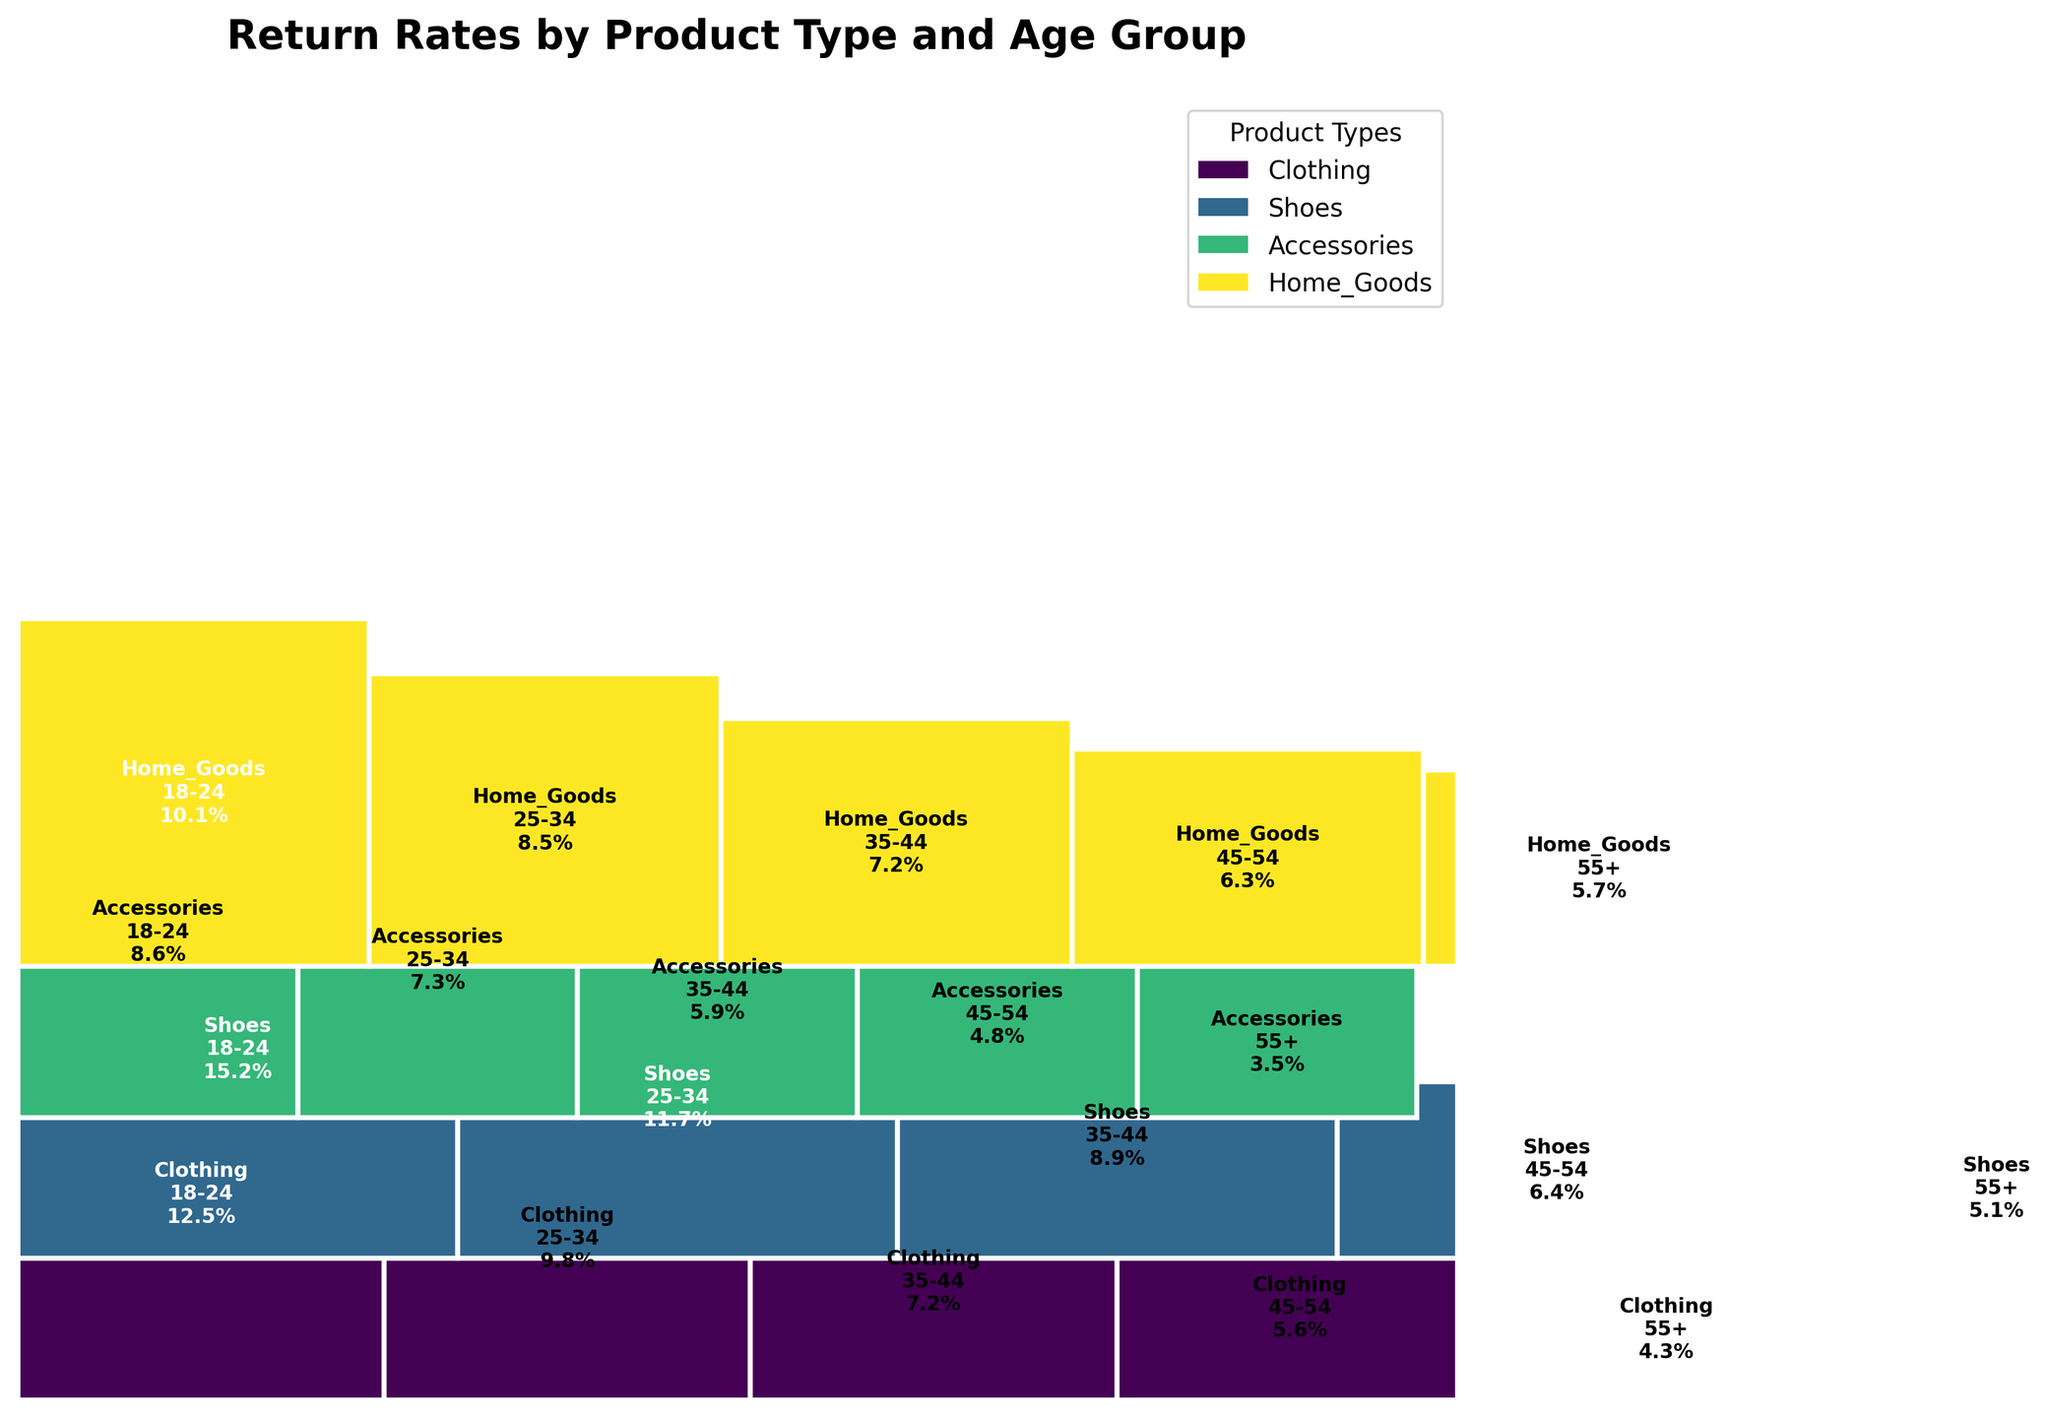How many product types are displayed in the plot? By counting the different labels within the legend that represents product types, we can see that there are four unique product types in the plot.
Answer: Four Which product type has the highest return rate for the age group 18-24? By looking at the section of the plot corresponding to the age group 18-24, we can observe the figures and see that Shoes have the highest return rate at 15.2%.
Answer: Shoes What is the average return rate for the age group 45-54 across all product types? We need to add the return rates for the age group 45-54 across Clothing (5.6), Shoes (6.4), Accessories (4.8), and Home Goods (6.3), and then divide by the number of product types. The calculation is (5.6 + 6.4 + 4.8 + 6.3) / 4 = 23.1 / 4.
Answer: 5.8% Which age group has the lowest return rate for Accessories, and what is the rate? By inspecting the plot, we can find that the age group 55+ has the lowest return rate for Accessories, at 3.5%.
Answer: 55+, 3.5% Compare the return rates for Clothing: Are return rates higher for younger age groups compared to older age groups? By observing the return rates for Clothing across different age groups: 12.5% (18-24), 9.8% (25-34), 7.2% (35-44), 5.6% (45-54), and 4.3% (55+), we can clearly see that return rates decrease as the age group increases.
Answer: Yes Which age group has the most variation in return rates across different product types? To determine this, we need to compare the range of return rates for each age group across different product types. The range for 18-24 is: 15.2% - 8.6% = 6.6%, 25-34: 11.7% - 7.3% = 4.4%, 35-44: 8.9% - 5.9% = 3%, 45-54: 6.4% - 4.8% = 1.6%, 55+: 5.7% - 3.5% = 2.2%. The 18-24 age group has the most variation.
Answer: 18-24 What is the total return rate for Home Goods across all age groups? By summing the return rates for Home Goods across all age groups: 10.1% (18-24), 8.5% (25-34), 7.2% (35-44), 6.3% (45-54), and 5.7% (55+), we get 10.1 + 8.5 + 7.2 + 6.3 + 5.7 = 37.8%.
Answer: 37.8% Is there any product type whose return rates do not decrease consistently with increasing age groups? By examining each product type's return rates across age groups, we observe that Home Goods' return rates do not show a consistent decrease because the rate for 55+ (5.7%) is slightly higher than the rate for 45-54 (5.6%).
Answer: Yes, Home Goods 